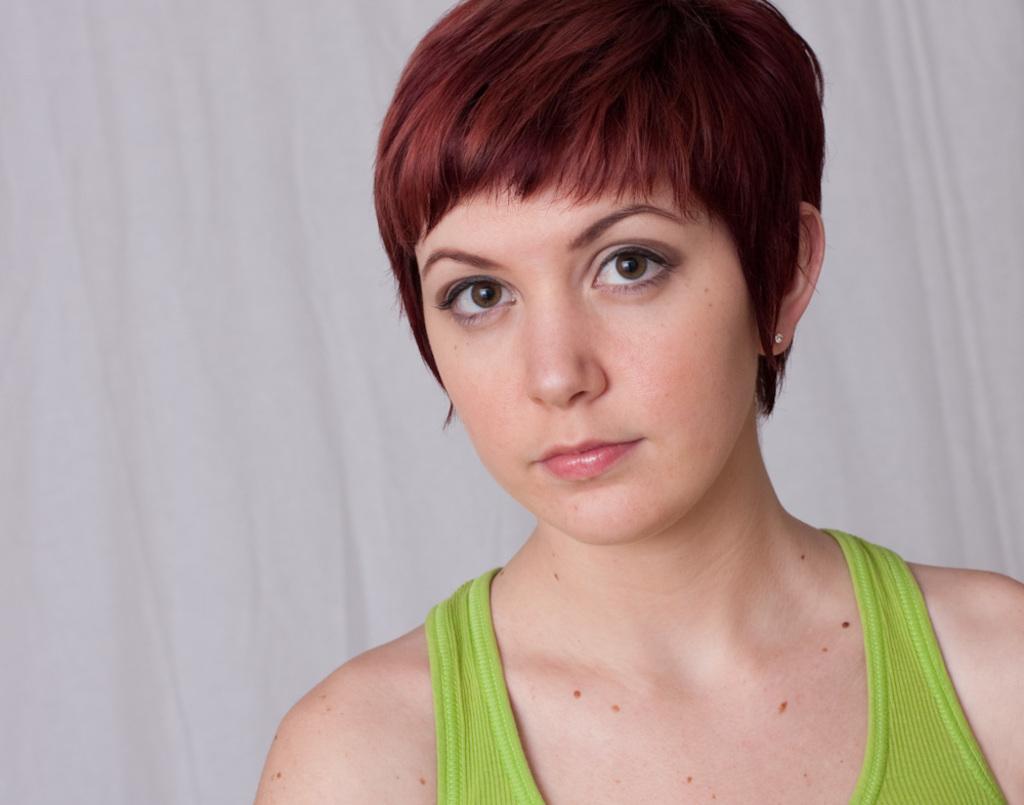Can you describe this image briefly? In this image I can see a woman and I can see she is wearing green colour dress. I can also see white colour in the background. 